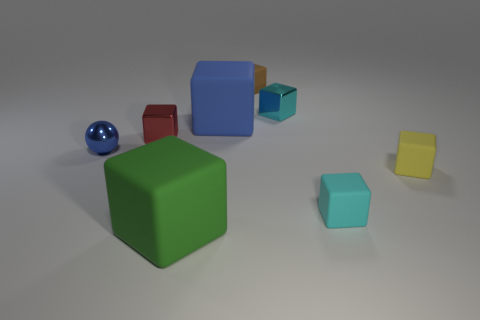Subtract 4 cubes. How many cubes are left? 3 Subtract all cyan shiny blocks. How many blocks are left? 6 Subtract all brown blocks. How many blocks are left? 6 Subtract all red cubes. Subtract all green spheres. How many cubes are left? 6 Add 1 tiny cyan matte objects. How many objects exist? 9 Subtract all balls. How many objects are left? 7 Subtract all brown shiny objects. Subtract all small cyan shiny things. How many objects are left? 7 Add 3 tiny cyan matte blocks. How many tiny cyan matte blocks are left? 4 Add 5 metal spheres. How many metal spheres exist? 6 Subtract 1 cyan blocks. How many objects are left? 7 